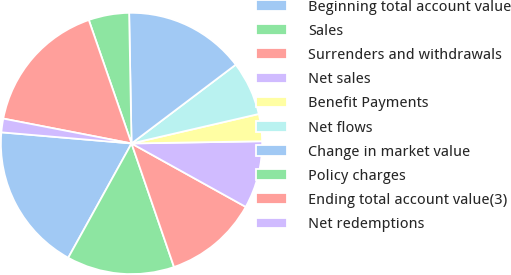Convert chart. <chart><loc_0><loc_0><loc_500><loc_500><pie_chart><fcel>Beginning total account value<fcel>Sales<fcel>Surrenders and withdrawals<fcel>Net sales<fcel>Benefit Payments<fcel>Net flows<fcel>Change in market value<fcel>Policy charges<fcel>Ending total account value(3)<fcel>Net redemptions<nl><fcel>18.31%<fcel>13.32%<fcel>11.66%<fcel>8.34%<fcel>3.35%<fcel>6.68%<fcel>14.99%<fcel>5.01%<fcel>16.65%<fcel>1.69%<nl></chart> 